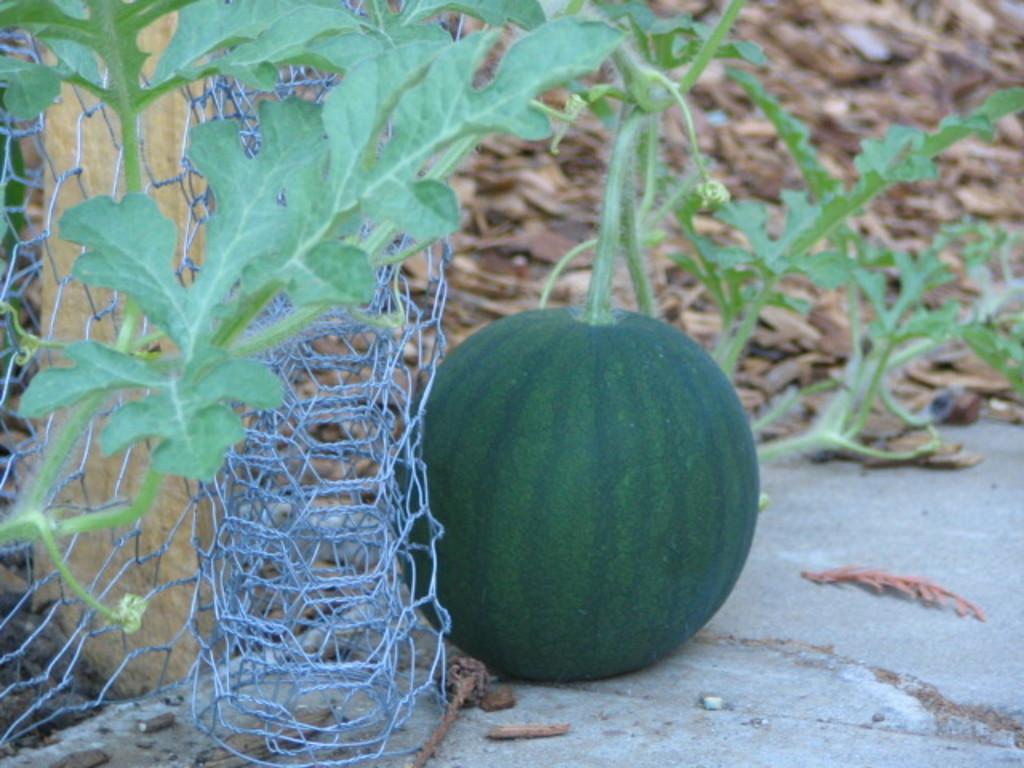In one or two sentences, can you explain what this image depicts? This picture is clicked outside. In the foreground we can see the ground and the metal net and we can see a watermelon and the plants. In the background we can see the dry leaves and some objects lying on the ground. 